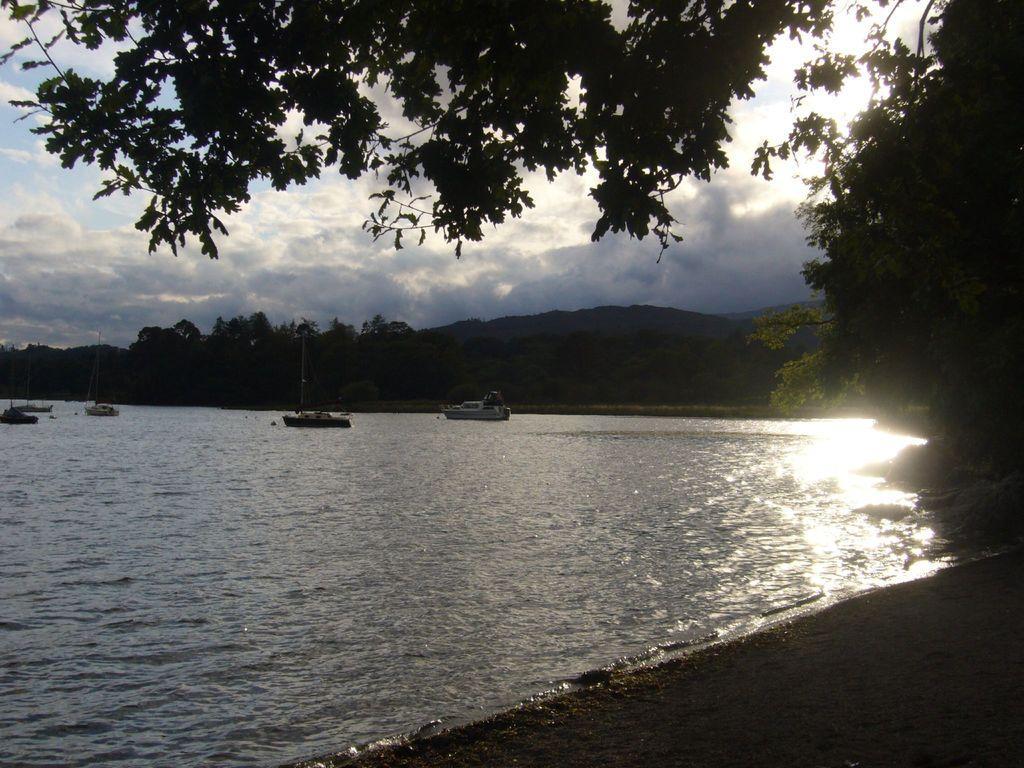Please provide a concise description of this image. In this picture we can see the boats are present on the water. In the background of the image we can see the hills and trees. On the right side of the image we can see the sun rays are present on the water. At the bottom of the image we can see the ground. At the top of the image we can see the clouds are present in the sky. 